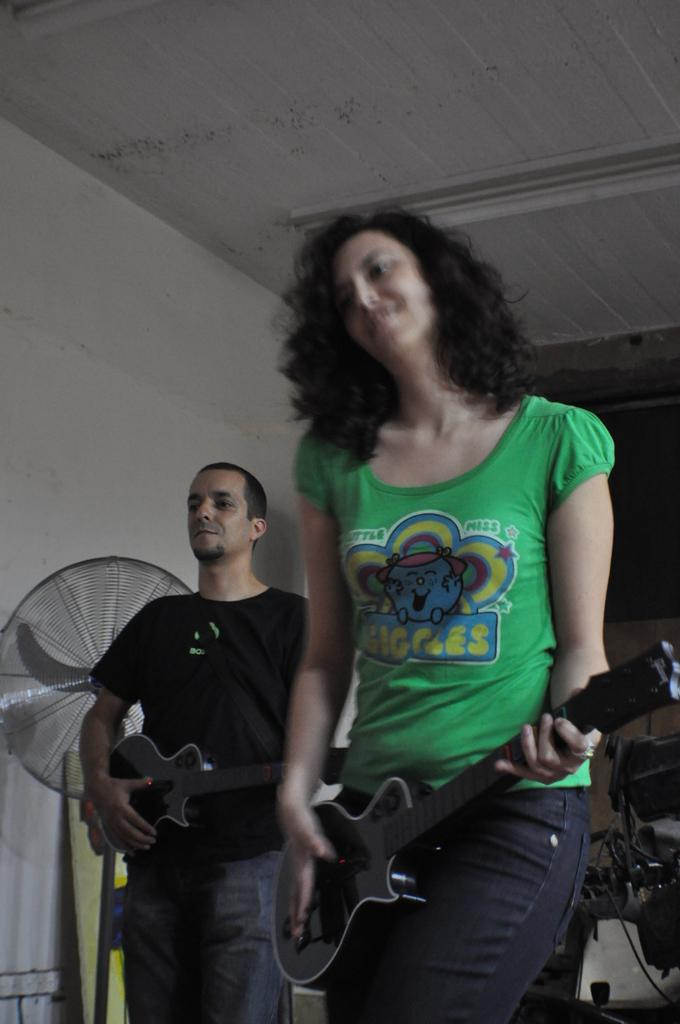How many people are in the image? There are two people in the image, a man and a woman. What are the man and woman doing in the image? Both the man and woman are standing and holding guitars. What can be seen in the background of the image? There is a fan and a wall in the background of the image. What is the weight of the debt the man and woman owe in the image? There is no mention of debt or any financial situation in the image, so it is not possible to determine the weight of any debt. 